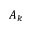Convert formula to latex. <formula><loc_0><loc_0><loc_500><loc_500>A _ { k }</formula> 